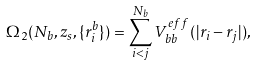Convert formula to latex. <formula><loc_0><loc_0><loc_500><loc_500>\Omega _ { 2 } ( N _ { b } , z _ { s } , \{ { r } _ { i } ^ { b } \} ) = \sum _ { i < j } ^ { N _ { b } } V _ { b b } ^ { e f f } ( | { r } _ { i } - { r } _ { j } | ) ,</formula> 